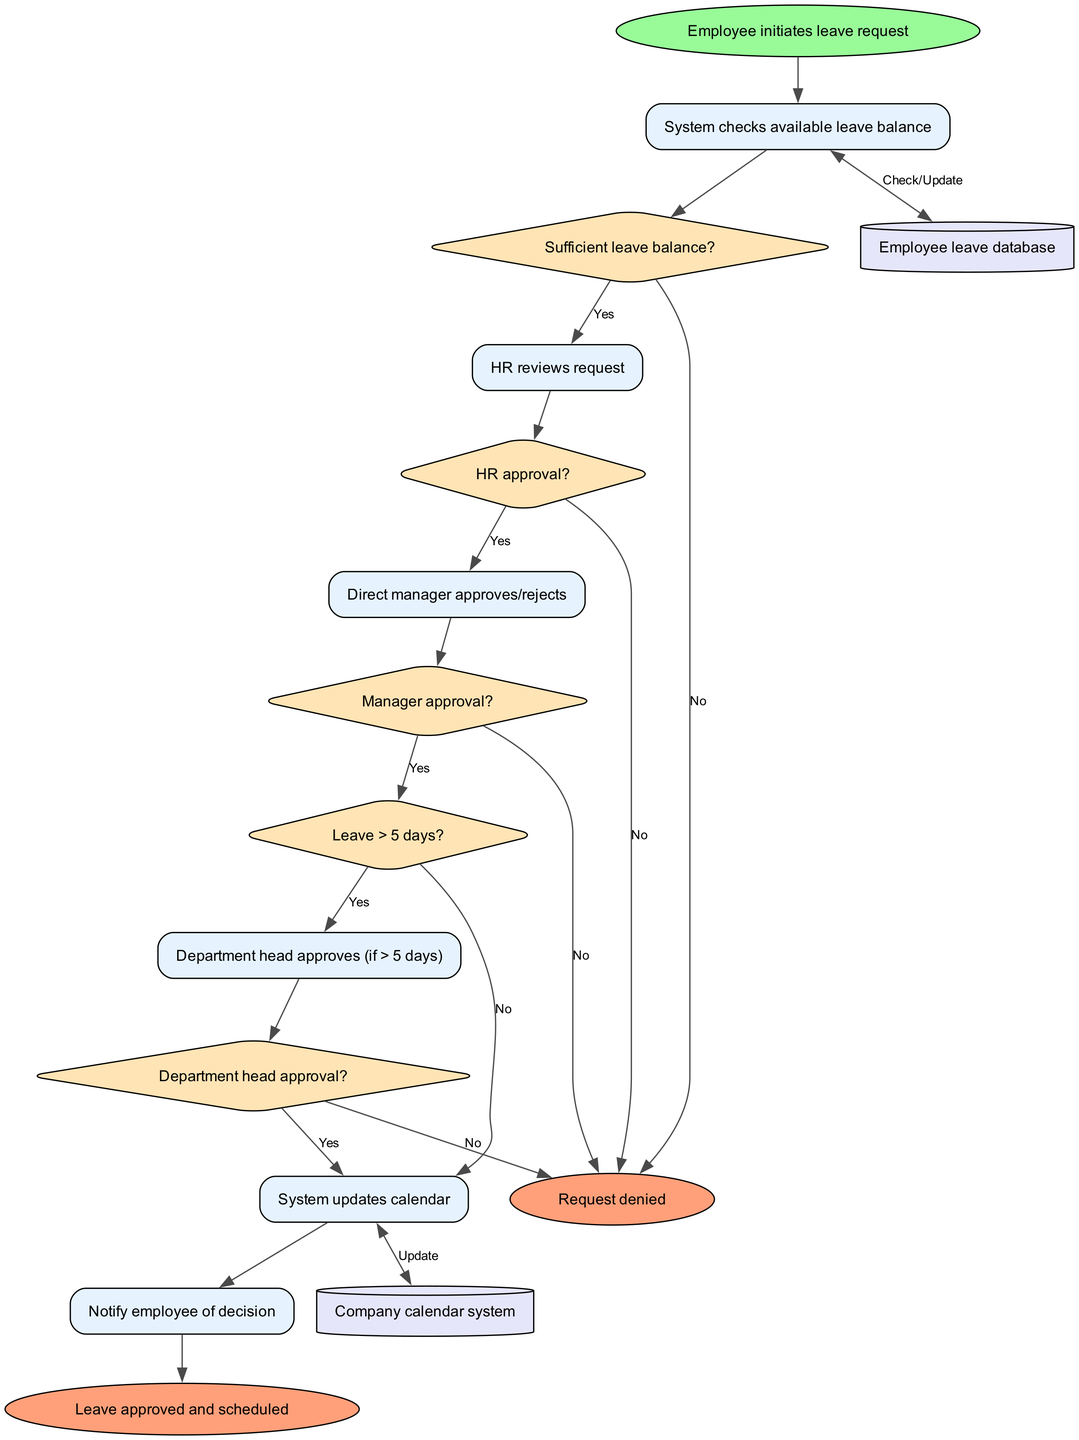What is the start node of the system? The start node of the system is where the process begins. According to the diagram data, the start node is "Employee initiates leave request."
Answer: Employee initiates leave request How many processes are in the flowchart? To find the number of processes, we count the items listed under the "processes" key in the diagram data. There are six processes defined.
Answer: 6 What happens after the system checks available leave balance? After the check, the flow proceeds to a decision node where it assesses if there is a "Sufficient leave balance?". This is the next step in the process after the initial check.
Answer: Sufficient leave balance? What is the last process in the leave request approval system? The last process in the flowchart is where the system notifies the employee of the decision made regarding their leave request. This happens after all necessary approvals.
Answer: Notify employee of decision If the direct manager rejects the leave request, what will happen next? If the direct manager rejects the request, the flow will lead to the "Request denied" end node. This means the leave request has been denied, thus concluding the process.
Answer: Request denied What condition must be met for department head approval to be required? The condition for department head approval to be required is if the leave requested is greater than 5 days. This necessitates an additional level of approval from the department head.
Answer: Leave > 5 days? How does the system update the calendar? The system updates the calendar after receiving the authorization from the direct manager or, if necessary, the department head. This step is essential for properly scheduling the approved leave.
Answer: Update calendar Which data stores are involved in this leave request approval system? The system employs two data stores as indicated in the flowchart: "Employee leave database" and "Company calendar system." Both are critical for managing leave requests and scheduling.
Answer: Employee leave database, Company calendar system What is the decision point after HR reviews the request? After HR reviews the request, the decision point is about whether the request can be approved based on the HR's assessment. This moves the flow to the "HR approval?" decision node.
Answer: HR approval? 